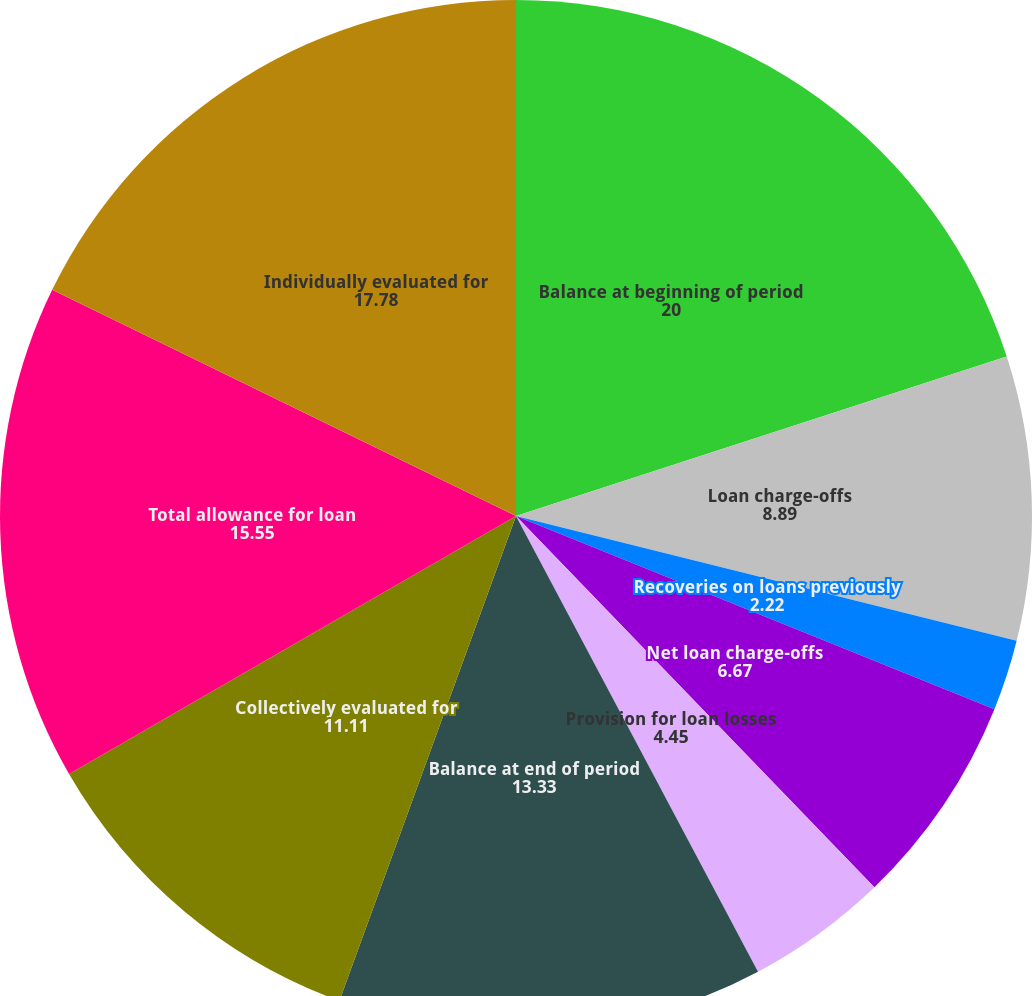Convert chart. <chart><loc_0><loc_0><loc_500><loc_500><pie_chart><fcel>Balance at beginning of period<fcel>Loan charge-offs<fcel>Recoveries on loans previously<fcel>Net loan charge-offs<fcel>Provision for loan losses<fcel>Balance at end of period<fcel>As a percentage of total loans<fcel>Collectively evaluated for<fcel>Total allowance for loan<fcel>Individually evaluated for<nl><fcel>20.0%<fcel>8.89%<fcel>2.22%<fcel>6.67%<fcel>4.45%<fcel>13.33%<fcel>0.0%<fcel>11.11%<fcel>15.55%<fcel>17.78%<nl></chart> 